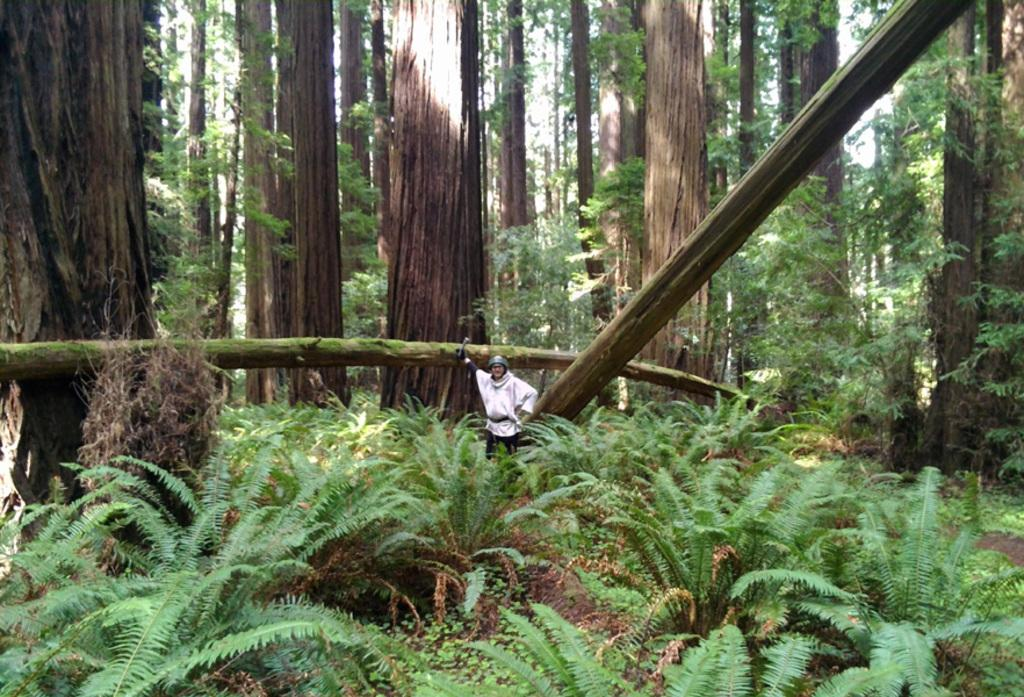What is the main subject of the image? There is a person standing in the image. What can be seen in the background of the image? There are plants and trees in the image. What type of honey is being collected by the person in the image? There is no honey or honey collection activity present in the image. How many bananas can be seen in the image? There are no bananas present in the image. 